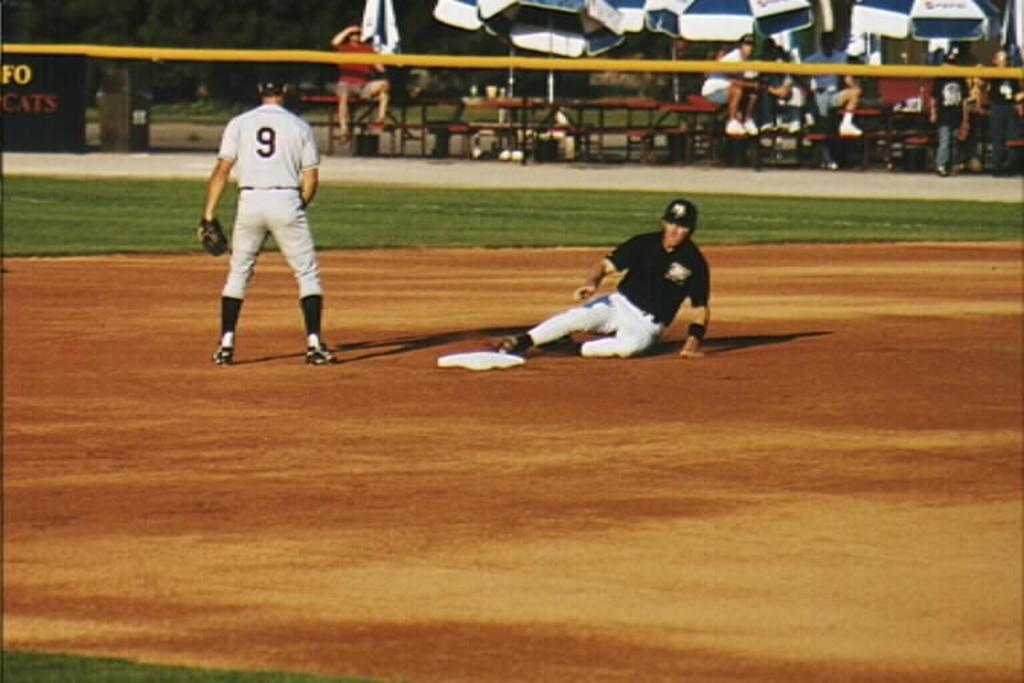<image>
Present a compact description of the photo's key features. A player slides into base while player 9 watches. 